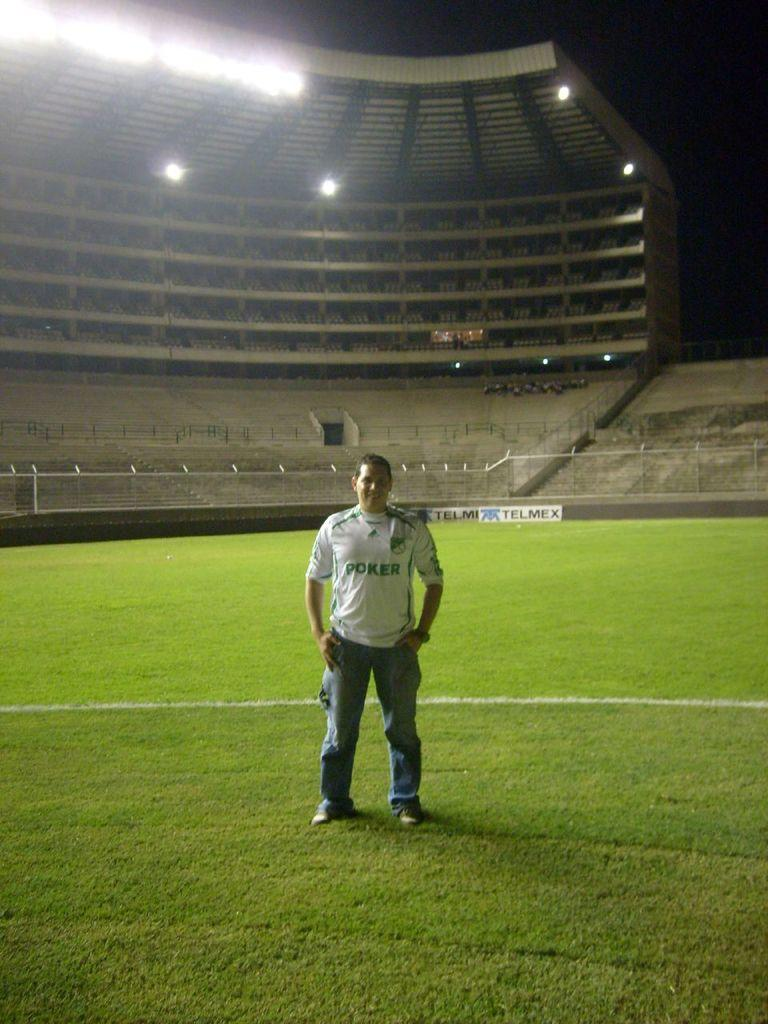<image>
Share a concise interpretation of the image provided. Man standing on a field with a white jersey that has Poker across the front of his shirt. 